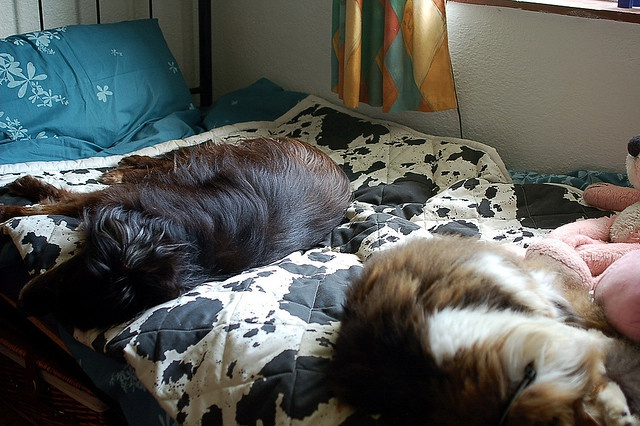Describe the objects in this image and their specific colors. I can see bed in darkgray, black, white, and gray tones, dog in darkgray, black, lightgray, and gray tones, dog in darkgray, black, and gray tones, and teddy bear in darkgray, lightgray, brown, and pink tones in this image. 